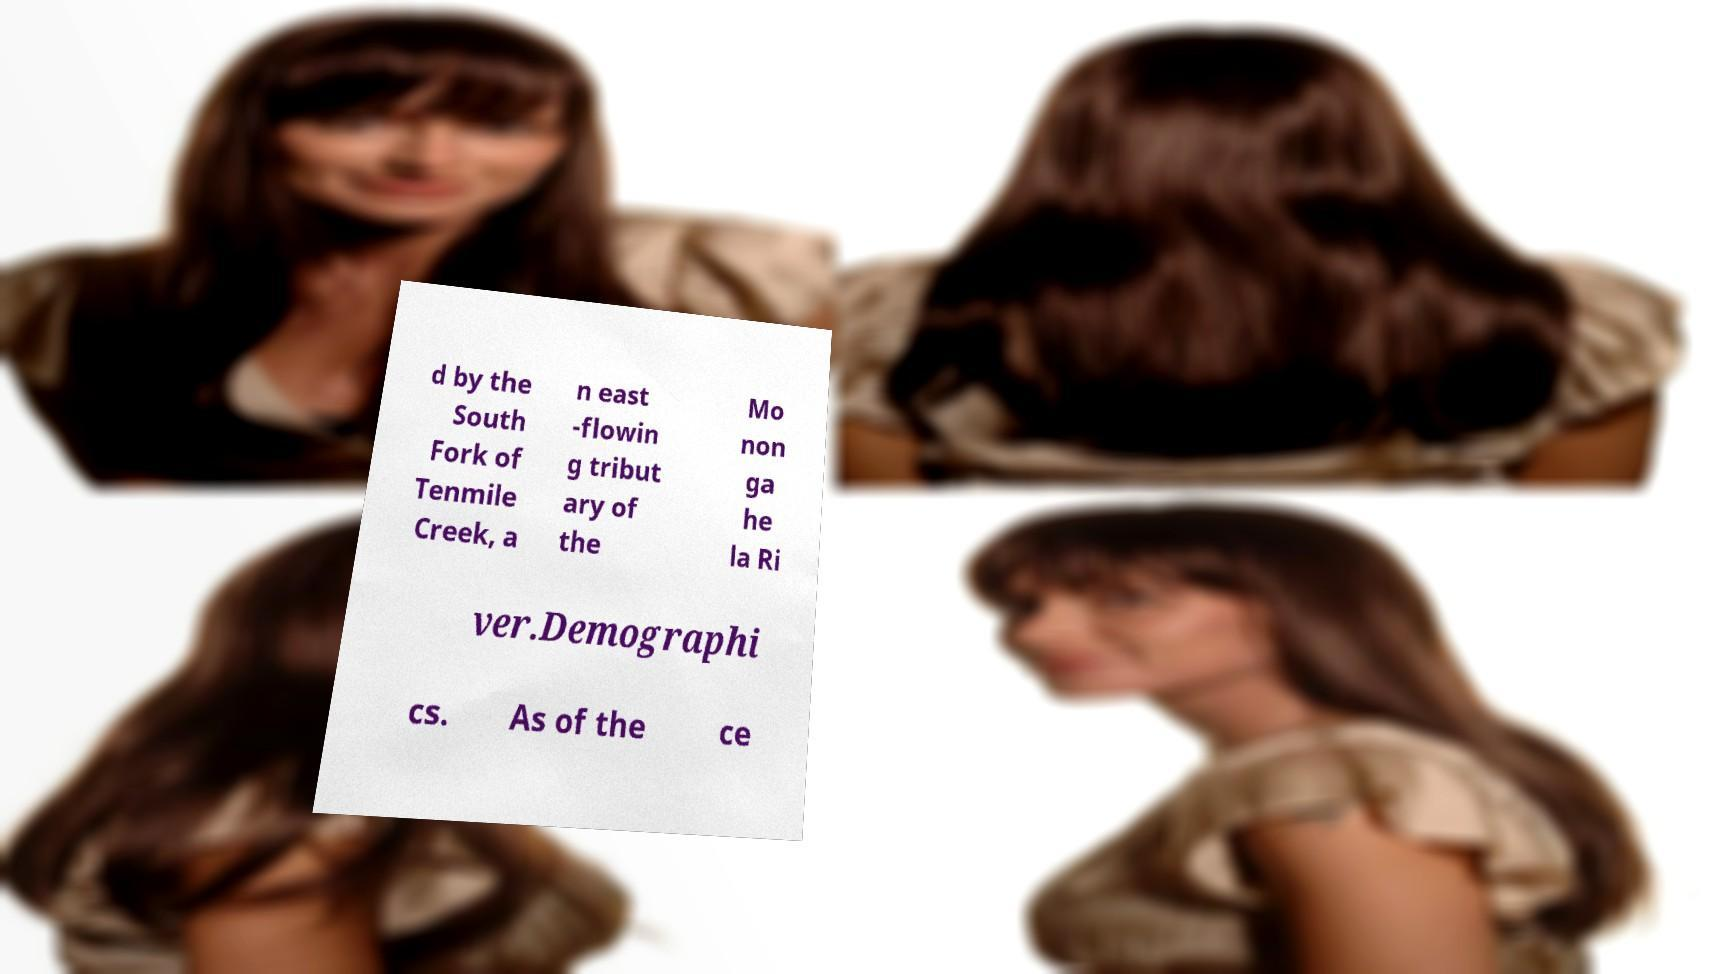Please read and relay the text visible in this image. What does it say? d by the South Fork of Tenmile Creek, a n east -flowin g tribut ary of the Mo non ga he la Ri ver.Demographi cs. As of the ce 